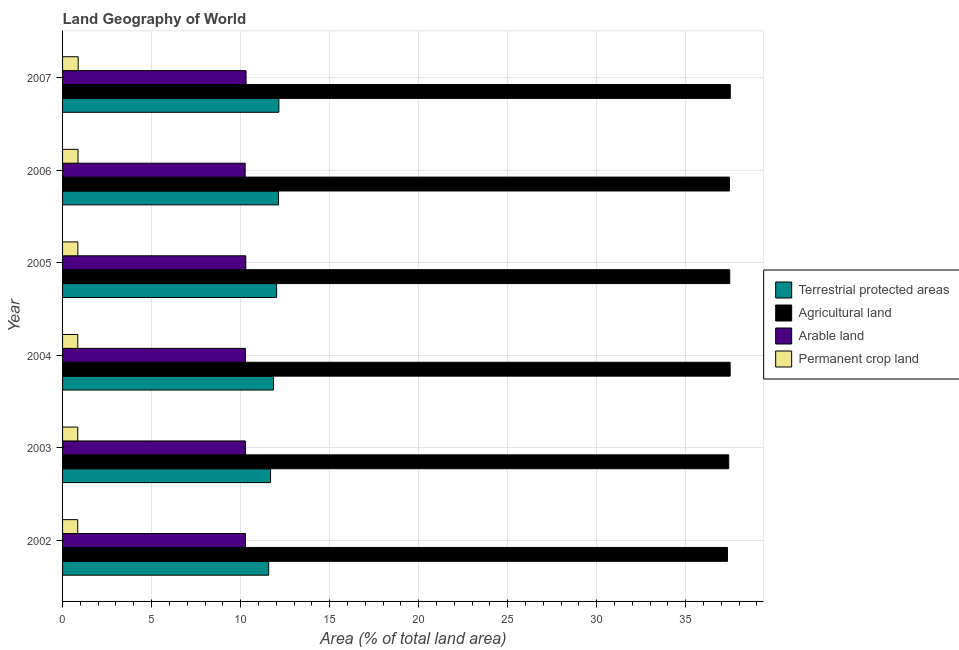How many different coloured bars are there?
Give a very brief answer. 4. Are the number of bars per tick equal to the number of legend labels?
Your answer should be compact. Yes. How many bars are there on the 1st tick from the top?
Offer a terse response. 4. How many bars are there on the 2nd tick from the bottom?
Provide a short and direct response. 4. What is the label of the 3rd group of bars from the top?
Ensure brevity in your answer.  2005. In how many cases, is the number of bars for a given year not equal to the number of legend labels?
Provide a short and direct response. 0. What is the percentage of area under arable land in 2003?
Ensure brevity in your answer.  10.27. Across all years, what is the maximum percentage of land under terrestrial protection?
Give a very brief answer. 12.15. Across all years, what is the minimum percentage of area under arable land?
Give a very brief answer. 10.25. In which year was the percentage of area under agricultural land maximum?
Your answer should be compact. 2007. What is the total percentage of land under terrestrial protection in the graph?
Your answer should be compact. 71.41. What is the difference between the percentage of area under permanent crop land in 2002 and that in 2005?
Your response must be concise. -0.01. What is the difference between the percentage of area under arable land in 2004 and the percentage of land under terrestrial protection in 2006?
Give a very brief answer. -1.86. What is the average percentage of area under agricultural land per year?
Your response must be concise. 37.45. In the year 2007, what is the difference between the percentage of land under terrestrial protection and percentage of area under agricultural land?
Keep it short and to the point. -25.35. What is the ratio of the percentage of area under arable land in 2003 to that in 2006?
Keep it short and to the point. 1. Is the percentage of area under arable land in 2003 less than that in 2004?
Offer a very short reply. No. What is the difference between the highest and the second highest percentage of area under permanent crop land?
Ensure brevity in your answer.  0.01. What is the difference between the highest and the lowest percentage of area under arable land?
Your answer should be very brief. 0.05. In how many years, is the percentage of land under terrestrial protection greater than the average percentage of land under terrestrial protection taken over all years?
Give a very brief answer. 3. What does the 3rd bar from the top in 2007 represents?
Your answer should be very brief. Agricultural land. What does the 2nd bar from the bottom in 2004 represents?
Offer a terse response. Agricultural land. Is it the case that in every year, the sum of the percentage of land under terrestrial protection and percentage of area under agricultural land is greater than the percentage of area under arable land?
Give a very brief answer. Yes. Are all the bars in the graph horizontal?
Provide a short and direct response. Yes. How many years are there in the graph?
Offer a very short reply. 6. What is the difference between two consecutive major ticks on the X-axis?
Offer a very short reply. 5. Does the graph contain grids?
Your response must be concise. Yes. Where does the legend appear in the graph?
Ensure brevity in your answer.  Center right. How are the legend labels stacked?
Offer a terse response. Vertical. What is the title of the graph?
Provide a short and direct response. Land Geography of World. What is the label or title of the X-axis?
Give a very brief answer. Area (% of total land area). What is the Area (% of total land area) in Terrestrial protected areas in 2002?
Your response must be concise. 11.58. What is the Area (% of total land area) of Agricultural land in 2002?
Make the answer very short. 37.34. What is the Area (% of total land area) of Arable land in 2002?
Your answer should be compact. 10.27. What is the Area (% of total land area) of Permanent crop land in 2002?
Keep it short and to the point. 0.85. What is the Area (% of total land area) in Terrestrial protected areas in 2003?
Your answer should be very brief. 11.68. What is the Area (% of total land area) of Agricultural land in 2003?
Your response must be concise. 37.42. What is the Area (% of total land area) in Arable land in 2003?
Provide a succinct answer. 10.27. What is the Area (% of total land area) in Permanent crop land in 2003?
Provide a short and direct response. 0.85. What is the Area (% of total land area) of Terrestrial protected areas in 2004?
Your response must be concise. 11.85. What is the Area (% of total land area) of Agricultural land in 2004?
Keep it short and to the point. 37.5. What is the Area (% of total land area) in Arable land in 2004?
Your answer should be compact. 10.27. What is the Area (% of total land area) of Permanent crop land in 2004?
Your answer should be compact. 0.85. What is the Area (% of total land area) in Terrestrial protected areas in 2005?
Your answer should be compact. 12.02. What is the Area (% of total land area) in Agricultural land in 2005?
Your answer should be compact. 37.47. What is the Area (% of total land area) in Arable land in 2005?
Ensure brevity in your answer.  10.29. What is the Area (% of total land area) in Permanent crop land in 2005?
Offer a very short reply. 0.86. What is the Area (% of total land area) of Terrestrial protected areas in 2006?
Your response must be concise. 12.13. What is the Area (% of total land area) of Agricultural land in 2006?
Your answer should be compact. 37.45. What is the Area (% of total land area) of Arable land in 2006?
Your response must be concise. 10.25. What is the Area (% of total land area) in Permanent crop land in 2006?
Ensure brevity in your answer.  0.87. What is the Area (% of total land area) in Terrestrial protected areas in 2007?
Provide a short and direct response. 12.15. What is the Area (% of total land area) of Agricultural land in 2007?
Your answer should be very brief. 37.5. What is the Area (% of total land area) of Arable land in 2007?
Make the answer very short. 10.31. What is the Area (% of total land area) in Permanent crop land in 2007?
Provide a short and direct response. 0.88. Across all years, what is the maximum Area (% of total land area) in Terrestrial protected areas?
Your answer should be very brief. 12.15. Across all years, what is the maximum Area (% of total land area) in Agricultural land?
Keep it short and to the point. 37.5. Across all years, what is the maximum Area (% of total land area) in Arable land?
Your response must be concise. 10.31. Across all years, what is the maximum Area (% of total land area) in Permanent crop land?
Your answer should be very brief. 0.88. Across all years, what is the minimum Area (% of total land area) of Terrestrial protected areas?
Make the answer very short. 11.58. Across all years, what is the minimum Area (% of total land area) of Agricultural land?
Offer a terse response. 37.34. Across all years, what is the minimum Area (% of total land area) of Arable land?
Your response must be concise. 10.25. Across all years, what is the minimum Area (% of total land area) in Permanent crop land?
Your answer should be compact. 0.85. What is the total Area (% of total land area) in Terrestrial protected areas in the graph?
Give a very brief answer. 71.41. What is the total Area (% of total land area) in Agricultural land in the graph?
Offer a terse response. 224.68. What is the total Area (% of total land area) in Arable land in the graph?
Your answer should be very brief. 61.66. What is the total Area (% of total land area) of Permanent crop land in the graph?
Make the answer very short. 5.16. What is the difference between the Area (% of total land area) of Terrestrial protected areas in 2002 and that in 2003?
Your answer should be very brief. -0.11. What is the difference between the Area (% of total land area) of Agricultural land in 2002 and that in 2003?
Offer a terse response. -0.07. What is the difference between the Area (% of total land area) in Arable land in 2002 and that in 2003?
Provide a succinct answer. 0. What is the difference between the Area (% of total land area) in Permanent crop land in 2002 and that in 2003?
Offer a very short reply. -0. What is the difference between the Area (% of total land area) of Terrestrial protected areas in 2002 and that in 2004?
Your answer should be very brief. -0.27. What is the difference between the Area (% of total land area) in Agricultural land in 2002 and that in 2004?
Give a very brief answer. -0.15. What is the difference between the Area (% of total land area) of Arable land in 2002 and that in 2004?
Make the answer very short. 0. What is the difference between the Area (% of total land area) of Permanent crop land in 2002 and that in 2004?
Ensure brevity in your answer.  -0. What is the difference between the Area (% of total land area) of Terrestrial protected areas in 2002 and that in 2005?
Your answer should be compact. -0.45. What is the difference between the Area (% of total land area) in Agricultural land in 2002 and that in 2005?
Your answer should be very brief. -0.13. What is the difference between the Area (% of total land area) in Arable land in 2002 and that in 2005?
Your answer should be very brief. -0.02. What is the difference between the Area (% of total land area) in Permanent crop land in 2002 and that in 2005?
Give a very brief answer. -0.01. What is the difference between the Area (% of total land area) in Terrestrial protected areas in 2002 and that in 2006?
Offer a very short reply. -0.55. What is the difference between the Area (% of total land area) in Agricultural land in 2002 and that in 2006?
Provide a succinct answer. -0.11. What is the difference between the Area (% of total land area) in Arable land in 2002 and that in 2006?
Your answer should be compact. 0.02. What is the difference between the Area (% of total land area) of Permanent crop land in 2002 and that in 2006?
Your answer should be compact. -0.02. What is the difference between the Area (% of total land area) of Terrestrial protected areas in 2002 and that in 2007?
Provide a short and direct response. -0.57. What is the difference between the Area (% of total land area) in Agricultural land in 2002 and that in 2007?
Offer a very short reply. -0.16. What is the difference between the Area (% of total land area) in Arable land in 2002 and that in 2007?
Give a very brief answer. -0.03. What is the difference between the Area (% of total land area) in Permanent crop land in 2002 and that in 2007?
Provide a short and direct response. -0.03. What is the difference between the Area (% of total land area) in Terrestrial protected areas in 2003 and that in 2004?
Offer a very short reply. -0.17. What is the difference between the Area (% of total land area) of Agricultural land in 2003 and that in 2004?
Keep it short and to the point. -0.08. What is the difference between the Area (% of total land area) of Arable land in 2003 and that in 2004?
Your response must be concise. 0. What is the difference between the Area (% of total land area) of Permanent crop land in 2003 and that in 2004?
Offer a terse response. -0. What is the difference between the Area (% of total land area) in Terrestrial protected areas in 2003 and that in 2005?
Provide a short and direct response. -0.34. What is the difference between the Area (% of total land area) in Agricultural land in 2003 and that in 2005?
Your response must be concise. -0.06. What is the difference between the Area (% of total land area) in Arable land in 2003 and that in 2005?
Make the answer very short. -0.02. What is the difference between the Area (% of total land area) of Permanent crop land in 2003 and that in 2005?
Your answer should be compact. -0.01. What is the difference between the Area (% of total land area) of Terrestrial protected areas in 2003 and that in 2006?
Offer a terse response. -0.44. What is the difference between the Area (% of total land area) of Agricultural land in 2003 and that in 2006?
Your response must be concise. -0.04. What is the difference between the Area (% of total land area) in Arable land in 2003 and that in 2006?
Give a very brief answer. 0.01. What is the difference between the Area (% of total land area) in Permanent crop land in 2003 and that in 2006?
Give a very brief answer. -0.02. What is the difference between the Area (% of total land area) in Terrestrial protected areas in 2003 and that in 2007?
Your response must be concise. -0.47. What is the difference between the Area (% of total land area) of Agricultural land in 2003 and that in 2007?
Make the answer very short. -0.09. What is the difference between the Area (% of total land area) of Arable land in 2003 and that in 2007?
Keep it short and to the point. -0.04. What is the difference between the Area (% of total land area) in Permanent crop land in 2003 and that in 2007?
Offer a terse response. -0.03. What is the difference between the Area (% of total land area) of Terrestrial protected areas in 2004 and that in 2005?
Keep it short and to the point. -0.17. What is the difference between the Area (% of total land area) of Agricultural land in 2004 and that in 2005?
Your response must be concise. 0.02. What is the difference between the Area (% of total land area) in Arable land in 2004 and that in 2005?
Your answer should be compact. -0.02. What is the difference between the Area (% of total land area) in Permanent crop land in 2004 and that in 2005?
Your answer should be very brief. -0. What is the difference between the Area (% of total land area) of Terrestrial protected areas in 2004 and that in 2006?
Keep it short and to the point. -0.28. What is the difference between the Area (% of total land area) in Agricultural land in 2004 and that in 2006?
Your response must be concise. 0.04. What is the difference between the Area (% of total land area) of Arable land in 2004 and that in 2006?
Give a very brief answer. 0.01. What is the difference between the Area (% of total land area) of Permanent crop land in 2004 and that in 2006?
Ensure brevity in your answer.  -0.01. What is the difference between the Area (% of total land area) of Terrestrial protected areas in 2004 and that in 2007?
Your answer should be compact. -0.3. What is the difference between the Area (% of total land area) of Agricultural land in 2004 and that in 2007?
Keep it short and to the point. -0.01. What is the difference between the Area (% of total land area) of Arable land in 2004 and that in 2007?
Make the answer very short. -0.04. What is the difference between the Area (% of total land area) of Permanent crop land in 2004 and that in 2007?
Give a very brief answer. -0.02. What is the difference between the Area (% of total land area) in Terrestrial protected areas in 2005 and that in 2006?
Keep it short and to the point. -0.1. What is the difference between the Area (% of total land area) of Agricultural land in 2005 and that in 2006?
Provide a short and direct response. 0.02. What is the difference between the Area (% of total land area) in Arable land in 2005 and that in 2006?
Make the answer very short. 0.04. What is the difference between the Area (% of total land area) in Permanent crop land in 2005 and that in 2006?
Your response must be concise. -0.01. What is the difference between the Area (% of total land area) in Terrestrial protected areas in 2005 and that in 2007?
Give a very brief answer. -0.13. What is the difference between the Area (% of total land area) in Agricultural land in 2005 and that in 2007?
Your answer should be very brief. -0.03. What is the difference between the Area (% of total land area) of Arable land in 2005 and that in 2007?
Keep it short and to the point. -0.01. What is the difference between the Area (% of total land area) in Permanent crop land in 2005 and that in 2007?
Keep it short and to the point. -0.02. What is the difference between the Area (% of total land area) in Terrestrial protected areas in 2006 and that in 2007?
Offer a very short reply. -0.02. What is the difference between the Area (% of total land area) of Agricultural land in 2006 and that in 2007?
Make the answer very short. -0.05. What is the difference between the Area (% of total land area) of Arable land in 2006 and that in 2007?
Keep it short and to the point. -0.05. What is the difference between the Area (% of total land area) of Permanent crop land in 2006 and that in 2007?
Give a very brief answer. -0.01. What is the difference between the Area (% of total land area) of Terrestrial protected areas in 2002 and the Area (% of total land area) of Agricultural land in 2003?
Give a very brief answer. -25.84. What is the difference between the Area (% of total land area) of Terrestrial protected areas in 2002 and the Area (% of total land area) of Arable land in 2003?
Give a very brief answer. 1.31. What is the difference between the Area (% of total land area) of Terrestrial protected areas in 2002 and the Area (% of total land area) of Permanent crop land in 2003?
Offer a very short reply. 10.72. What is the difference between the Area (% of total land area) in Agricultural land in 2002 and the Area (% of total land area) in Arable land in 2003?
Offer a terse response. 27.08. What is the difference between the Area (% of total land area) in Agricultural land in 2002 and the Area (% of total land area) in Permanent crop land in 2003?
Offer a very short reply. 36.49. What is the difference between the Area (% of total land area) in Arable land in 2002 and the Area (% of total land area) in Permanent crop land in 2003?
Provide a short and direct response. 9.42. What is the difference between the Area (% of total land area) of Terrestrial protected areas in 2002 and the Area (% of total land area) of Agricultural land in 2004?
Offer a terse response. -25.92. What is the difference between the Area (% of total land area) of Terrestrial protected areas in 2002 and the Area (% of total land area) of Arable land in 2004?
Make the answer very short. 1.31. What is the difference between the Area (% of total land area) in Terrestrial protected areas in 2002 and the Area (% of total land area) in Permanent crop land in 2004?
Offer a terse response. 10.72. What is the difference between the Area (% of total land area) of Agricultural land in 2002 and the Area (% of total land area) of Arable land in 2004?
Keep it short and to the point. 27.08. What is the difference between the Area (% of total land area) of Agricultural land in 2002 and the Area (% of total land area) of Permanent crop land in 2004?
Make the answer very short. 36.49. What is the difference between the Area (% of total land area) in Arable land in 2002 and the Area (% of total land area) in Permanent crop land in 2004?
Provide a short and direct response. 9.42. What is the difference between the Area (% of total land area) in Terrestrial protected areas in 2002 and the Area (% of total land area) in Agricultural land in 2005?
Your answer should be compact. -25.89. What is the difference between the Area (% of total land area) in Terrestrial protected areas in 2002 and the Area (% of total land area) in Arable land in 2005?
Your answer should be very brief. 1.29. What is the difference between the Area (% of total land area) of Terrestrial protected areas in 2002 and the Area (% of total land area) of Permanent crop land in 2005?
Your response must be concise. 10.72. What is the difference between the Area (% of total land area) in Agricultural land in 2002 and the Area (% of total land area) in Arable land in 2005?
Keep it short and to the point. 27.05. What is the difference between the Area (% of total land area) of Agricultural land in 2002 and the Area (% of total land area) of Permanent crop land in 2005?
Keep it short and to the point. 36.49. What is the difference between the Area (% of total land area) of Arable land in 2002 and the Area (% of total land area) of Permanent crop land in 2005?
Offer a very short reply. 9.42. What is the difference between the Area (% of total land area) of Terrestrial protected areas in 2002 and the Area (% of total land area) of Agricultural land in 2006?
Ensure brevity in your answer.  -25.88. What is the difference between the Area (% of total land area) in Terrestrial protected areas in 2002 and the Area (% of total land area) in Arable land in 2006?
Provide a succinct answer. 1.32. What is the difference between the Area (% of total land area) in Terrestrial protected areas in 2002 and the Area (% of total land area) in Permanent crop land in 2006?
Your answer should be compact. 10.71. What is the difference between the Area (% of total land area) of Agricultural land in 2002 and the Area (% of total land area) of Arable land in 2006?
Provide a short and direct response. 27.09. What is the difference between the Area (% of total land area) of Agricultural land in 2002 and the Area (% of total land area) of Permanent crop land in 2006?
Your answer should be very brief. 36.48. What is the difference between the Area (% of total land area) in Arable land in 2002 and the Area (% of total land area) in Permanent crop land in 2006?
Your answer should be very brief. 9.4. What is the difference between the Area (% of total land area) of Terrestrial protected areas in 2002 and the Area (% of total land area) of Agricultural land in 2007?
Offer a very short reply. -25.93. What is the difference between the Area (% of total land area) in Terrestrial protected areas in 2002 and the Area (% of total land area) in Arable land in 2007?
Provide a succinct answer. 1.27. What is the difference between the Area (% of total land area) of Terrestrial protected areas in 2002 and the Area (% of total land area) of Permanent crop land in 2007?
Your answer should be very brief. 10.7. What is the difference between the Area (% of total land area) in Agricultural land in 2002 and the Area (% of total land area) in Arable land in 2007?
Give a very brief answer. 27.04. What is the difference between the Area (% of total land area) in Agricultural land in 2002 and the Area (% of total land area) in Permanent crop land in 2007?
Offer a terse response. 36.47. What is the difference between the Area (% of total land area) in Arable land in 2002 and the Area (% of total land area) in Permanent crop land in 2007?
Provide a succinct answer. 9.4. What is the difference between the Area (% of total land area) in Terrestrial protected areas in 2003 and the Area (% of total land area) in Agricultural land in 2004?
Give a very brief answer. -25.81. What is the difference between the Area (% of total land area) in Terrestrial protected areas in 2003 and the Area (% of total land area) in Arable land in 2004?
Offer a terse response. 1.41. What is the difference between the Area (% of total land area) of Terrestrial protected areas in 2003 and the Area (% of total land area) of Permanent crop land in 2004?
Keep it short and to the point. 10.83. What is the difference between the Area (% of total land area) of Agricultural land in 2003 and the Area (% of total land area) of Arable land in 2004?
Your response must be concise. 27.15. What is the difference between the Area (% of total land area) in Agricultural land in 2003 and the Area (% of total land area) in Permanent crop land in 2004?
Provide a succinct answer. 36.56. What is the difference between the Area (% of total land area) in Arable land in 2003 and the Area (% of total land area) in Permanent crop land in 2004?
Ensure brevity in your answer.  9.41. What is the difference between the Area (% of total land area) in Terrestrial protected areas in 2003 and the Area (% of total land area) in Agricultural land in 2005?
Keep it short and to the point. -25.79. What is the difference between the Area (% of total land area) in Terrestrial protected areas in 2003 and the Area (% of total land area) in Arable land in 2005?
Keep it short and to the point. 1.39. What is the difference between the Area (% of total land area) in Terrestrial protected areas in 2003 and the Area (% of total land area) in Permanent crop land in 2005?
Offer a very short reply. 10.82. What is the difference between the Area (% of total land area) of Agricultural land in 2003 and the Area (% of total land area) of Arable land in 2005?
Your answer should be very brief. 27.12. What is the difference between the Area (% of total land area) of Agricultural land in 2003 and the Area (% of total land area) of Permanent crop land in 2005?
Your response must be concise. 36.56. What is the difference between the Area (% of total land area) in Arable land in 2003 and the Area (% of total land area) in Permanent crop land in 2005?
Give a very brief answer. 9.41. What is the difference between the Area (% of total land area) of Terrestrial protected areas in 2003 and the Area (% of total land area) of Agricultural land in 2006?
Ensure brevity in your answer.  -25.77. What is the difference between the Area (% of total land area) of Terrestrial protected areas in 2003 and the Area (% of total land area) of Arable land in 2006?
Provide a short and direct response. 1.43. What is the difference between the Area (% of total land area) of Terrestrial protected areas in 2003 and the Area (% of total land area) of Permanent crop land in 2006?
Keep it short and to the point. 10.81. What is the difference between the Area (% of total land area) in Agricultural land in 2003 and the Area (% of total land area) in Arable land in 2006?
Keep it short and to the point. 27.16. What is the difference between the Area (% of total land area) of Agricultural land in 2003 and the Area (% of total land area) of Permanent crop land in 2006?
Provide a short and direct response. 36.55. What is the difference between the Area (% of total land area) of Arable land in 2003 and the Area (% of total land area) of Permanent crop land in 2006?
Offer a very short reply. 9.4. What is the difference between the Area (% of total land area) in Terrestrial protected areas in 2003 and the Area (% of total land area) in Agricultural land in 2007?
Ensure brevity in your answer.  -25.82. What is the difference between the Area (% of total land area) in Terrestrial protected areas in 2003 and the Area (% of total land area) in Arable land in 2007?
Keep it short and to the point. 1.38. What is the difference between the Area (% of total land area) in Terrestrial protected areas in 2003 and the Area (% of total land area) in Permanent crop land in 2007?
Make the answer very short. 10.81. What is the difference between the Area (% of total land area) in Agricultural land in 2003 and the Area (% of total land area) in Arable land in 2007?
Give a very brief answer. 27.11. What is the difference between the Area (% of total land area) of Agricultural land in 2003 and the Area (% of total land area) of Permanent crop land in 2007?
Offer a very short reply. 36.54. What is the difference between the Area (% of total land area) of Arable land in 2003 and the Area (% of total land area) of Permanent crop land in 2007?
Give a very brief answer. 9.39. What is the difference between the Area (% of total land area) of Terrestrial protected areas in 2004 and the Area (% of total land area) of Agricultural land in 2005?
Provide a short and direct response. -25.62. What is the difference between the Area (% of total land area) in Terrestrial protected areas in 2004 and the Area (% of total land area) in Arable land in 2005?
Keep it short and to the point. 1.56. What is the difference between the Area (% of total land area) of Terrestrial protected areas in 2004 and the Area (% of total land area) of Permanent crop land in 2005?
Your answer should be compact. 10.99. What is the difference between the Area (% of total land area) of Agricultural land in 2004 and the Area (% of total land area) of Arable land in 2005?
Provide a short and direct response. 27.2. What is the difference between the Area (% of total land area) of Agricultural land in 2004 and the Area (% of total land area) of Permanent crop land in 2005?
Offer a very short reply. 36.64. What is the difference between the Area (% of total land area) in Arable land in 2004 and the Area (% of total land area) in Permanent crop land in 2005?
Provide a short and direct response. 9.41. What is the difference between the Area (% of total land area) of Terrestrial protected areas in 2004 and the Area (% of total land area) of Agricultural land in 2006?
Offer a terse response. -25.6. What is the difference between the Area (% of total land area) in Terrestrial protected areas in 2004 and the Area (% of total land area) in Arable land in 2006?
Offer a very short reply. 1.59. What is the difference between the Area (% of total land area) of Terrestrial protected areas in 2004 and the Area (% of total land area) of Permanent crop land in 2006?
Give a very brief answer. 10.98. What is the difference between the Area (% of total land area) of Agricultural land in 2004 and the Area (% of total land area) of Arable land in 2006?
Ensure brevity in your answer.  27.24. What is the difference between the Area (% of total land area) in Agricultural land in 2004 and the Area (% of total land area) in Permanent crop land in 2006?
Provide a succinct answer. 36.63. What is the difference between the Area (% of total land area) of Arable land in 2004 and the Area (% of total land area) of Permanent crop land in 2006?
Keep it short and to the point. 9.4. What is the difference between the Area (% of total land area) of Terrestrial protected areas in 2004 and the Area (% of total land area) of Agricultural land in 2007?
Ensure brevity in your answer.  -25.65. What is the difference between the Area (% of total land area) in Terrestrial protected areas in 2004 and the Area (% of total land area) in Arable land in 2007?
Give a very brief answer. 1.54. What is the difference between the Area (% of total land area) of Terrestrial protected areas in 2004 and the Area (% of total land area) of Permanent crop land in 2007?
Your response must be concise. 10.97. What is the difference between the Area (% of total land area) in Agricultural land in 2004 and the Area (% of total land area) in Arable land in 2007?
Ensure brevity in your answer.  27.19. What is the difference between the Area (% of total land area) of Agricultural land in 2004 and the Area (% of total land area) of Permanent crop land in 2007?
Your response must be concise. 36.62. What is the difference between the Area (% of total land area) in Arable land in 2004 and the Area (% of total land area) in Permanent crop land in 2007?
Your response must be concise. 9.39. What is the difference between the Area (% of total land area) in Terrestrial protected areas in 2005 and the Area (% of total land area) in Agricultural land in 2006?
Give a very brief answer. -25.43. What is the difference between the Area (% of total land area) of Terrestrial protected areas in 2005 and the Area (% of total land area) of Arable land in 2006?
Provide a short and direct response. 1.77. What is the difference between the Area (% of total land area) of Terrestrial protected areas in 2005 and the Area (% of total land area) of Permanent crop land in 2006?
Ensure brevity in your answer.  11.16. What is the difference between the Area (% of total land area) of Agricultural land in 2005 and the Area (% of total land area) of Arable land in 2006?
Your answer should be compact. 27.22. What is the difference between the Area (% of total land area) in Agricultural land in 2005 and the Area (% of total land area) in Permanent crop land in 2006?
Provide a short and direct response. 36.6. What is the difference between the Area (% of total land area) of Arable land in 2005 and the Area (% of total land area) of Permanent crop land in 2006?
Provide a succinct answer. 9.42. What is the difference between the Area (% of total land area) in Terrestrial protected areas in 2005 and the Area (% of total land area) in Agricultural land in 2007?
Keep it short and to the point. -25.48. What is the difference between the Area (% of total land area) in Terrestrial protected areas in 2005 and the Area (% of total land area) in Arable land in 2007?
Ensure brevity in your answer.  1.72. What is the difference between the Area (% of total land area) in Terrestrial protected areas in 2005 and the Area (% of total land area) in Permanent crop land in 2007?
Provide a short and direct response. 11.15. What is the difference between the Area (% of total land area) of Agricultural land in 2005 and the Area (% of total land area) of Arable land in 2007?
Your answer should be compact. 27.17. What is the difference between the Area (% of total land area) of Agricultural land in 2005 and the Area (% of total land area) of Permanent crop land in 2007?
Offer a terse response. 36.59. What is the difference between the Area (% of total land area) of Arable land in 2005 and the Area (% of total land area) of Permanent crop land in 2007?
Make the answer very short. 9.41. What is the difference between the Area (% of total land area) in Terrestrial protected areas in 2006 and the Area (% of total land area) in Agricultural land in 2007?
Provide a succinct answer. -25.38. What is the difference between the Area (% of total land area) of Terrestrial protected areas in 2006 and the Area (% of total land area) of Arable land in 2007?
Offer a very short reply. 1.82. What is the difference between the Area (% of total land area) in Terrestrial protected areas in 2006 and the Area (% of total land area) in Permanent crop land in 2007?
Your answer should be very brief. 11.25. What is the difference between the Area (% of total land area) of Agricultural land in 2006 and the Area (% of total land area) of Arable land in 2007?
Make the answer very short. 27.15. What is the difference between the Area (% of total land area) in Agricultural land in 2006 and the Area (% of total land area) in Permanent crop land in 2007?
Your response must be concise. 36.58. What is the difference between the Area (% of total land area) in Arable land in 2006 and the Area (% of total land area) in Permanent crop land in 2007?
Provide a succinct answer. 9.38. What is the average Area (% of total land area) of Terrestrial protected areas per year?
Ensure brevity in your answer.  11.9. What is the average Area (% of total land area) in Agricultural land per year?
Provide a short and direct response. 37.45. What is the average Area (% of total land area) in Arable land per year?
Offer a terse response. 10.28. What is the average Area (% of total land area) in Permanent crop land per year?
Offer a very short reply. 0.86. In the year 2002, what is the difference between the Area (% of total land area) in Terrestrial protected areas and Area (% of total land area) in Agricultural land?
Make the answer very short. -25.77. In the year 2002, what is the difference between the Area (% of total land area) in Terrestrial protected areas and Area (% of total land area) in Arable land?
Your response must be concise. 1.3. In the year 2002, what is the difference between the Area (% of total land area) in Terrestrial protected areas and Area (% of total land area) in Permanent crop land?
Make the answer very short. 10.73. In the year 2002, what is the difference between the Area (% of total land area) in Agricultural land and Area (% of total land area) in Arable land?
Offer a very short reply. 27.07. In the year 2002, what is the difference between the Area (% of total land area) in Agricultural land and Area (% of total land area) in Permanent crop land?
Your answer should be very brief. 36.49. In the year 2002, what is the difference between the Area (% of total land area) in Arable land and Area (% of total land area) in Permanent crop land?
Provide a succinct answer. 9.42. In the year 2003, what is the difference between the Area (% of total land area) in Terrestrial protected areas and Area (% of total land area) in Agricultural land?
Provide a succinct answer. -25.73. In the year 2003, what is the difference between the Area (% of total land area) in Terrestrial protected areas and Area (% of total land area) in Arable land?
Your answer should be compact. 1.41. In the year 2003, what is the difference between the Area (% of total land area) in Terrestrial protected areas and Area (% of total land area) in Permanent crop land?
Provide a succinct answer. 10.83. In the year 2003, what is the difference between the Area (% of total land area) in Agricultural land and Area (% of total land area) in Arable land?
Make the answer very short. 27.15. In the year 2003, what is the difference between the Area (% of total land area) of Agricultural land and Area (% of total land area) of Permanent crop land?
Your answer should be very brief. 36.56. In the year 2003, what is the difference between the Area (% of total land area) in Arable land and Area (% of total land area) in Permanent crop land?
Offer a terse response. 9.42. In the year 2004, what is the difference between the Area (% of total land area) of Terrestrial protected areas and Area (% of total land area) of Agricultural land?
Offer a very short reply. -25.65. In the year 2004, what is the difference between the Area (% of total land area) of Terrestrial protected areas and Area (% of total land area) of Arable land?
Ensure brevity in your answer.  1.58. In the year 2004, what is the difference between the Area (% of total land area) in Terrestrial protected areas and Area (% of total land area) in Permanent crop land?
Your answer should be very brief. 11. In the year 2004, what is the difference between the Area (% of total land area) of Agricultural land and Area (% of total land area) of Arable land?
Offer a terse response. 27.23. In the year 2004, what is the difference between the Area (% of total land area) in Agricultural land and Area (% of total land area) in Permanent crop land?
Offer a very short reply. 36.64. In the year 2004, what is the difference between the Area (% of total land area) in Arable land and Area (% of total land area) in Permanent crop land?
Provide a succinct answer. 9.41. In the year 2005, what is the difference between the Area (% of total land area) of Terrestrial protected areas and Area (% of total land area) of Agricultural land?
Ensure brevity in your answer.  -25.45. In the year 2005, what is the difference between the Area (% of total land area) of Terrestrial protected areas and Area (% of total land area) of Arable land?
Give a very brief answer. 1.73. In the year 2005, what is the difference between the Area (% of total land area) of Terrestrial protected areas and Area (% of total land area) of Permanent crop land?
Make the answer very short. 11.17. In the year 2005, what is the difference between the Area (% of total land area) in Agricultural land and Area (% of total land area) in Arable land?
Give a very brief answer. 27.18. In the year 2005, what is the difference between the Area (% of total land area) of Agricultural land and Area (% of total land area) of Permanent crop land?
Your answer should be compact. 36.61. In the year 2005, what is the difference between the Area (% of total land area) of Arable land and Area (% of total land area) of Permanent crop land?
Ensure brevity in your answer.  9.43. In the year 2006, what is the difference between the Area (% of total land area) in Terrestrial protected areas and Area (% of total land area) in Agricultural land?
Ensure brevity in your answer.  -25.33. In the year 2006, what is the difference between the Area (% of total land area) in Terrestrial protected areas and Area (% of total land area) in Arable land?
Your answer should be compact. 1.87. In the year 2006, what is the difference between the Area (% of total land area) in Terrestrial protected areas and Area (% of total land area) in Permanent crop land?
Your answer should be compact. 11.26. In the year 2006, what is the difference between the Area (% of total land area) of Agricultural land and Area (% of total land area) of Arable land?
Make the answer very short. 27.2. In the year 2006, what is the difference between the Area (% of total land area) in Agricultural land and Area (% of total land area) in Permanent crop land?
Your answer should be very brief. 36.59. In the year 2006, what is the difference between the Area (% of total land area) of Arable land and Area (% of total land area) of Permanent crop land?
Your answer should be very brief. 9.39. In the year 2007, what is the difference between the Area (% of total land area) of Terrestrial protected areas and Area (% of total land area) of Agricultural land?
Offer a terse response. -25.35. In the year 2007, what is the difference between the Area (% of total land area) in Terrestrial protected areas and Area (% of total land area) in Arable land?
Your response must be concise. 1.84. In the year 2007, what is the difference between the Area (% of total land area) in Terrestrial protected areas and Area (% of total land area) in Permanent crop land?
Keep it short and to the point. 11.27. In the year 2007, what is the difference between the Area (% of total land area) of Agricultural land and Area (% of total land area) of Arable land?
Offer a very short reply. 27.2. In the year 2007, what is the difference between the Area (% of total land area) in Agricultural land and Area (% of total land area) in Permanent crop land?
Provide a succinct answer. 36.62. In the year 2007, what is the difference between the Area (% of total land area) in Arable land and Area (% of total land area) in Permanent crop land?
Provide a succinct answer. 9.43. What is the ratio of the Area (% of total land area) in Arable land in 2002 to that in 2003?
Offer a terse response. 1. What is the ratio of the Area (% of total land area) of Agricultural land in 2002 to that in 2004?
Your response must be concise. 1. What is the ratio of the Area (% of total land area) in Terrestrial protected areas in 2002 to that in 2005?
Provide a short and direct response. 0.96. What is the ratio of the Area (% of total land area) in Permanent crop land in 2002 to that in 2005?
Offer a very short reply. 0.99. What is the ratio of the Area (% of total land area) in Terrestrial protected areas in 2002 to that in 2006?
Give a very brief answer. 0.95. What is the ratio of the Area (% of total land area) in Permanent crop land in 2002 to that in 2006?
Provide a succinct answer. 0.98. What is the ratio of the Area (% of total land area) of Terrestrial protected areas in 2002 to that in 2007?
Your answer should be very brief. 0.95. What is the ratio of the Area (% of total land area) of Permanent crop land in 2002 to that in 2007?
Your answer should be compact. 0.97. What is the ratio of the Area (% of total land area) of Terrestrial protected areas in 2003 to that in 2004?
Your response must be concise. 0.99. What is the ratio of the Area (% of total land area) of Agricultural land in 2003 to that in 2004?
Make the answer very short. 1. What is the ratio of the Area (% of total land area) of Permanent crop land in 2003 to that in 2004?
Offer a very short reply. 1. What is the ratio of the Area (% of total land area) of Terrestrial protected areas in 2003 to that in 2005?
Make the answer very short. 0.97. What is the ratio of the Area (% of total land area) in Agricultural land in 2003 to that in 2005?
Your answer should be very brief. 1. What is the ratio of the Area (% of total land area) in Terrestrial protected areas in 2003 to that in 2006?
Provide a succinct answer. 0.96. What is the ratio of the Area (% of total land area) in Arable land in 2003 to that in 2006?
Your response must be concise. 1. What is the ratio of the Area (% of total land area) in Permanent crop land in 2003 to that in 2006?
Provide a succinct answer. 0.98. What is the ratio of the Area (% of total land area) in Terrestrial protected areas in 2003 to that in 2007?
Give a very brief answer. 0.96. What is the ratio of the Area (% of total land area) of Arable land in 2003 to that in 2007?
Provide a short and direct response. 1. What is the ratio of the Area (% of total land area) in Permanent crop land in 2003 to that in 2007?
Your answer should be compact. 0.97. What is the ratio of the Area (% of total land area) of Terrestrial protected areas in 2004 to that in 2005?
Keep it short and to the point. 0.99. What is the ratio of the Area (% of total land area) of Agricultural land in 2004 to that in 2005?
Your answer should be compact. 1. What is the ratio of the Area (% of total land area) of Arable land in 2004 to that in 2005?
Keep it short and to the point. 1. What is the ratio of the Area (% of total land area) of Terrestrial protected areas in 2004 to that in 2006?
Ensure brevity in your answer.  0.98. What is the ratio of the Area (% of total land area) of Arable land in 2004 to that in 2006?
Your answer should be compact. 1. What is the ratio of the Area (% of total land area) in Permanent crop land in 2004 to that in 2006?
Give a very brief answer. 0.98. What is the ratio of the Area (% of total land area) of Terrestrial protected areas in 2004 to that in 2007?
Your response must be concise. 0.98. What is the ratio of the Area (% of total land area) in Agricultural land in 2004 to that in 2007?
Offer a terse response. 1. What is the ratio of the Area (% of total land area) of Permanent crop land in 2004 to that in 2007?
Give a very brief answer. 0.97. What is the ratio of the Area (% of total land area) in Terrestrial protected areas in 2005 to that in 2006?
Provide a short and direct response. 0.99. What is the ratio of the Area (% of total land area) of Permanent crop land in 2005 to that in 2006?
Your answer should be very brief. 0.99. What is the ratio of the Area (% of total land area) in Arable land in 2005 to that in 2007?
Your answer should be compact. 1. What is the ratio of the Area (% of total land area) in Permanent crop land in 2005 to that in 2007?
Offer a terse response. 0.98. What is the ratio of the Area (% of total land area) of Terrestrial protected areas in 2006 to that in 2007?
Your response must be concise. 1. What is the difference between the highest and the second highest Area (% of total land area) of Terrestrial protected areas?
Keep it short and to the point. 0.02. What is the difference between the highest and the second highest Area (% of total land area) of Agricultural land?
Make the answer very short. 0.01. What is the difference between the highest and the second highest Area (% of total land area) in Arable land?
Keep it short and to the point. 0.01. What is the difference between the highest and the second highest Area (% of total land area) in Permanent crop land?
Offer a very short reply. 0.01. What is the difference between the highest and the lowest Area (% of total land area) of Terrestrial protected areas?
Keep it short and to the point. 0.57. What is the difference between the highest and the lowest Area (% of total land area) of Agricultural land?
Your answer should be compact. 0.16. What is the difference between the highest and the lowest Area (% of total land area) of Arable land?
Provide a short and direct response. 0.05. What is the difference between the highest and the lowest Area (% of total land area) in Permanent crop land?
Ensure brevity in your answer.  0.03. 